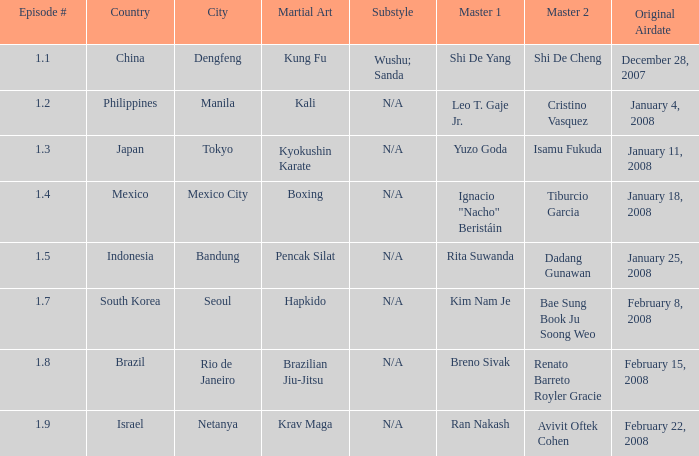Which martial arts style was shown in Rio de Janeiro? Brazilian Jiu-Jitsu. 